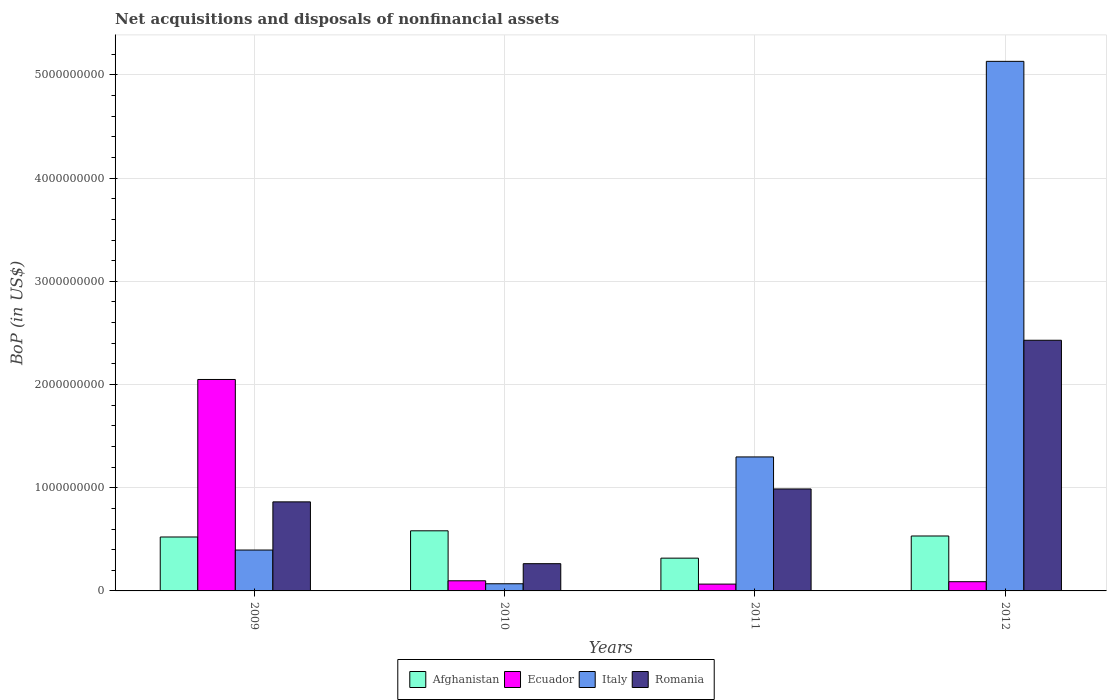How many bars are there on the 1st tick from the right?
Your answer should be compact. 4. What is the label of the 3rd group of bars from the left?
Provide a succinct answer. 2011. In how many cases, is the number of bars for a given year not equal to the number of legend labels?
Keep it short and to the point. 0. What is the Balance of Payments in Romania in 2012?
Your answer should be very brief. 2.43e+09. Across all years, what is the maximum Balance of Payments in Ecuador?
Keep it short and to the point. 2.05e+09. Across all years, what is the minimum Balance of Payments in Afghanistan?
Your response must be concise. 3.18e+08. In which year was the Balance of Payments in Afghanistan maximum?
Ensure brevity in your answer.  2010. What is the total Balance of Payments in Italy in the graph?
Your response must be concise. 6.90e+09. What is the difference between the Balance of Payments in Italy in 2009 and that in 2011?
Keep it short and to the point. -9.02e+08. What is the difference between the Balance of Payments in Italy in 2011 and the Balance of Payments in Ecuador in 2010?
Keep it short and to the point. 1.20e+09. What is the average Balance of Payments in Italy per year?
Offer a terse response. 1.72e+09. In the year 2012, what is the difference between the Balance of Payments in Afghanistan and Balance of Payments in Romania?
Offer a very short reply. -1.90e+09. What is the ratio of the Balance of Payments in Italy in 2009 to that in 2011?
Provide a succinct answer. 0.31. Is the difference between the Balance of Payments in Afghanistan in 2010 and 2011 greater than the difference between the Balance of Payments in Romania in 2010 and 2011?
Provide a succinct answer. Yes. What is the difference between the highest and the second highest Balance of Payments in Romania?
Your response must be concise. 1.44e+09. What is the difference between the highest and the lowest Balance of Payments in Afghanistan?
Ensure brevity in your answer.  2.65e+08. In how many years, is the Balance of Payments in Afghanistan greater than the average Balance of Payments in Afghanistan taken over all years?
Your response must be concise. 3. Is it the case that in every year, the sum of the Balance of Payments in Italy and Balance of Payments in Ecuador is greater than the sum of Balance of Payments in Romania and Balance of Payments in Afghanistan?
Provide a succinct answer. No. What does the 4th bar from the left in 2010 represents?
Give a very brief answer. Romania. What does the 3rd bar from the right in 2012 represents?
Make the answer very short. Ecuador. Is it the case that in every year, the sum of the Balance of Payments in Romania and Balance of Payments in Ecuador is greater than the Balance of Payments in Afghanistan?
Your answer should be compact. No. Are all the bars in the graph horizontal?
Ensure brevity in your answer.  No. What is the difference between two consecutive major ticks on the Y-axis?
Your answer should be compact. 1.00e+09. Are the values on the major ticks of Y-axis written in scientific E-notation?
Offer a terse response. No. How many legend labels are there?
Give a very brief answer. 4. How are the legend labels stacked?
Provide a succinct answer. Horizontal. What is the title of the graph?
Your answer should be compact. Net acquisitions and disposals of nonfinancial assets. Does "Europe(all income levels)" appear as one of the legend labels in the graph?
Offer a terse response. No. What is the label or title of the X-axis?
Ensure brevity in your answer.  Years. What is the label or title of the Y-axis?
Offer a very short reply. BoP (in US$). What is the BoP (in US$) in Afghanistan in 2009?
Keep it short and to the point. 5.23e+08. What is the BoP (in US$) in Ecuador in 2009?
Offer a very short reply. 2.05e+09. What is the BoP (in US$) in Italy in 2009?
Offer a terse response. 3.96e+08. What is the BoP (in US$) of Romania in 2009?
Keep it short and to the point. 8.63e+08. What is the BoP (in US$) of Afghanistan in 2010?
Offer a very short reply. 5.83e+08. What is the BoP (in US$) in Ecuador in 2010?
Give a very brief answer. 9.82e+07. What is the BoP (in US$) of Italy in 2010?
Provide a short and direct response. 6.94e+07. What is the BoP (in US$) in Romania in 2010?
Offer a terse response. 2.64e+08. What is the BoP (in US$) of Afghanistan in 2011?
Your response must be concise. 3.18e+08. What is the BoP (in US$) in Ecuador in 2011?
Give a very brief answer. 6.60e+07. What is the BoP (in US$) in Italy in 2011?
Your answer should be very brief. 1.30e+09. What is the BoP (in US$) of Romania in 2011?
Your response must be concise. 9.88e+08. What is the BoP (in US$) of Afghanistan in 2012?
Provide a short and direct response. 5.32e+08. What is the BoP (in US$) of Ecuador in 2012?
Your answer should be very brief. 8.94e+07. What is the BoP (in US$) of Italy in 2012?
Make the answer very short. 5.13e+09. What is the BoP (in US$) of Romania in 2012?
Your answer should be very brief. 2.43e+09. Across all years, what is the maximum BoP (in US$) of Afghanistan?
Ensure brevity in your answer.  5.83e+08. Across all years, what is the maximum BoP (in US$) of Ecuador?
Provide a succinct answer. 2.05e+09. Across all years, what is the maximum BoP (in US$) of Italy?
Keep it short and to the point. 5.13e+09. Across all years, what is the maximum BoP (in US$) in Romania?
Provide a succinct answer. 2.43e+09. Across all years, what is the minimum BoP (in US$) of Afghanistan?
Make the answer very short. 3.18e+08. Across all years, what is the minimum BoP (in US$) in Ecuador?
Provide a succinct answer. 6.60e+07. Across all years, what is the minimum BoP (in US$) in Italy?
Your response must be concise. 6.94e+07. Across all years, what is the minimum BoP (in US$) in Romania?
Your answer should be compact. 2.64e+08. What is the total BoP (in US$) in Afghanistan in the graph?
Keep it short and to the point. 1.95e+09. What is the total BoP (in US$) in Ecuador in the graph?
Your answer should be very brief. 2.30e+09. What is the total BoP (in US$) of Italy in the graph?
Your answer should be very brief. 6.90e+09. What is the total BoP (in US$) of Romania in the graph?
Provide a succinct answer. 4.54e+09. What is the difference between the BoP (in US$) in Afghanistan in 2009 and that in 2010?
Give a very brief answer. -6.00e+07. What is the difference between the BoP (in US$) of Ecuador in 2009 and that in 2010?
Give a very brief answer. 1.95e+09. What is the difference between the BoP (in US$) in Italy in 2009 and that in 2010?
Your answer should be compact. 3.27e+08. What is the difference between the BoP (in US$) of Romania in 2009 and that in 2010?
Give a very brief answer. 5.99e+08. What is the difference between the BoP (in US$) of Afghanistan in 2009 and that in 2011?
Offer a terse response. 2.05e+08. What is the difference between the BoP (in US$) of Ecuador in 2009 and that in 2011?
Give a very brief answer. 1.98e+09. What is the difference between the BoP (in US$) of Italy in 2009 and that in 2011?
Make the answer very short. -9.02e+08. What is the difference between the BoP (in US$) in Romania in 2009 and that in 2011?
Give a very brief answer. -1.25e+08. What is the difference between the BoP (in US$) of Afghanistan in 2009 and that in 2012?
Make the answer very short. -9.77e+06. What is the difference between the BoP (in US$) of Ecuador in 2009 and that in 2012?
Your response must be concise. 1.96e+09. What is the difference between the BoP (in US$) in Italy in 2009 and that in 2012?
Provide a short and direct response. -4.74e+09. What is the difference between the BoP (in US$) of Romania in 2009 and that in 2012?
Provide a short and direct response. -1.57e+09. What is the difference between the BoP (in US$) in Afghanistan in 2010 and that in 2011?
Keep it short and to the point. 2.65e+08. What is the difference between the BoP (in US$) of Ecuador in 2010 and that in 2011?
Make the answer very short. 3.22e+07. What is the difference between the BoP (in US$) of Italy in 2010 and that in 2011?
Ensure brevity in your answer.  -1.23e+09. What is the difference between the BoP (in US$) of Romania in 2010 and that in 2011?
Your answer should be compact. -7.24e+08. What is the difference between the BoP (in US$) of Afghanistan in 2010 and that in 2012?
Give a very brief answer. 5.02e+07. What is the difference between the BoP (in US$) in Ecuador in 2010 and that in 2012?
Offer a terse response. 8.86e+06. What is the difference between the BoP (in US$) of Italy in 2010 and that in 2012?
Make the answer very short. -5.06e+09. What is the difference between the BoP (in US$) in Romania in 2010 and that in 2012?
Offer a terse response. -2.16e+09. What is the difference between the BoP (in US$) in Afghanistan in 2011 and that in 2012?
Your answer should be compact. -2.15e+08. What is the difference between the BoP (in US$) of Ecuador in 2011 and that in 2012?
Your answer should be compact. -2.34e+07. What is the difference between the BoP (in US$) of Italy in 2011 and that in 2012?
Ensure brevity in your answer.  -3.83e+09. What is the difference between the BoP (in US$) in Romania in 2011 and that in 2012?
Your answer should be very brief. -1.44e+09. What is the difference between the BoP (in US$) in Afghanistan in 2009 and the BoP (in US$) in Ecuador in 2010?
Offer a very short reply. 4.24e+08. What is the difference between the BoP (in US$) in Afghanistan in 2009 and the BoP (in US$) in Italy in 2010?
Give a very brief answer. 4.53e+08. What is the difference between the BoP (in US$) of Afghanistan in 2009 and the BoP (in US$) of Romania in 2010?
Your answer should be very brief. 2.59e+08. What is the difference between the BoP (in US$) of Ecuador in 2009 and the BoP (in US$) of Italy in 2010?
Offer a terse response. 1.98e+09. What is the difference between the BoP (in US$) of Ecuador in 2009 and the BoP (in US$) of Romania in 2010?
Keep it short and to the point. 1.78e+09. What is the difference between the BoP (in US$) in Italy in 2009 and the BoP (in US$) in Romania in 2010?
Give a very brief answer. 1.32e+08. What is the difference between the BoP (in US$) of Afghanistan in 2009 and the BoP (in US$) of Ecuador in 2011?
Your answer should be compact. 4.57e+08. What is the difference between the BoP (in US$) of Afghanistan in 2009 and the BoP (in US$) of Italy in 2011?
Offer a terse response. -7.76e+08. What is the difference between the BoP (in US$) in Afghanistan in 2009 and the BoP (in US$) in Romania in 2011?
Offer a terse response. -4.65e+08. What is the difference between the BoP (in US$) in Ecuador in 2009 and the BoP (in US$) in Italy in 2011?
Keep it short and to the point. 7.51e+08. What is the difference between the BoP (in US$) of Ecuador in 2009 and the BoP (in US$) of Romania in 2011?
Ensure brevity in your answer.  1.06e+09. What is the difference between the BoP (in US$) of Italy in 2009 and the BoP (in US$) of Romania in 2011?
Offer a terse response. -5.92e+08. What is the difference between the BoP (in US$) in Afghanistan in 2009 and the BoP (in US$) in Ecuador in 2012?
Ensure brevity in your answer.  4.33e+08. What is the difference between the BoP (in US$) in Afghanistan in 2009 and the BoP (in US$) in Italy in 2012?
Offer a terse response. -4.61e+09. What is the difference between the BoP (in US$) of Afghanistan in 2009 and the BoP (in US$) of Romania in 2012?
Give a very brief answer. -1.91e+09. What is the difference between the BoP (in US$) in Ecuador in 2009 and the BoP (in US$) in Italy in 2012?
Keep it short and to the point. -3.08e+09. What is the difference between the BoP (in US$) in Ecuador in 2009 and the BoP (in US$) in Romania in 2012?
Give a very brief answer. -3.80e+08. What is the difference between the BoP (in US$) of Italy in 2009 and the BoP (in US$) of Romania in 2012?
Provide a succinct answer. -2.03e+09. What is the difference between the BoP (in US$) of Afghanistan in 2010 and the BoP (in US$) of Ecuador in 2011?
Make the answer very short. 5.17e+08. What is the difference between the BoP (in US$) in Afghanistan in 2010 and the BoP (in US$) in Italy in 2011?
Provide a short and direct response. -7.16e+08. What is the difference between the BoP (in US$) in Afghanistan in 2010 and the BoP (in US$) in Romania in 2011?
Offer a very short reply. -4.05e+08. What is the difference between the BoP (in US$) of Ecuador in 2010 and the BoP (in US$) of Italy in 2011?
Provide a succinct answer. -1.20e+09. What is the difference between the BoP (in US$) in Ecuador in 2010 and the BoP (in US$) in Romania in 2011?
Give a very brief answer. -8.90e+08. What is the difference between the BoP (in US$) of Italy in 2010 and the BoP (in US$) of Romania in 2011?
Provide a short and direct response. -9.19e+08. What is the difference between the BoP (in US$) of Afghanistan in 2010 and the BoP (in US$) of Ecuador in 2012?
Offer a terse response. 4.93e+08. What is the difference between the BoP (in US$) in Afghanistan in 2010 and the BoP (in US$) in Italy in 2012?
Make the answer very short. -4.55e+09. What is the difference between the BoP (in US$) in Afghanistan in 2010 and the BoP (in US$) in Romania in 2012?
Provide a short and direct response. -1.85e+09. What is the difference between the BoP (in US$) of Ecuador in 2010 and the BoP (in US$) of Italy in 2012?
Ensure brevity in your answer.  -5.03e+09. What is the difference between the BoP (in US$) of Ecuador in 2010 and the BoP (in US$) of Romania in 2012?
Offer a very short reply. -2.33e+09. What is the difference between the BoP (in US$) in Italy in 2010 and the BoP (in US$) in Romania in 2012?
Offer a very short reply. -2.36e+09. What is the difference between the BoP (in US$) of Afghanistan in 2011 and the BoP (in US$) of Ecuador in 2012?
Your answer should be very brief. 2.28e+08. What is the difference between the BoP (in US$) of Afghanistan in 2011 and the BoP (in US$) of Italy in 2012?
Your answer should be very brief. -4.81e+09. What is the difference between the BoP (in US$) of Afghanistan in 2011 and the BoP (in US$) of Romania in 2012?
Your answer should be compact. -2.11e+09. What is the difference between the BoP (in US$) in Ecuador in 2011 and the BoP (in US$) in Italy in 2012?
Keep it short and to the point. -5.07e+09. What is the difference between the BoP (in US$) of Ecuador in 2011 and the BoP (in US$) of Romania in 2012?
Your response must be concise. -2.36e+09. What is the difference between the BoP (in US$) in Italy in 2011 and the BoP (in US$) in Romania in 2012?
Offer a terse response. -1.13e+09. What is the average BoP (in US$) in Afghanistan per year?
Offer a very short reply. 4.89e+08. What is the average BoP (in US$) of Ecuador per year?
Your answer should be very brief. 5.76e+08. What is the average BoP (in US$) in Italy per year?
Offer a very short reply. 1.72e+09. What is the average BoP (in US$) in Romania per year?
Keep it short and to the point. 1.14e+09. In the year 2009, what is the difference between the BoP (in US$) in Afghanistan and BoP (in US$) in Ecuador?
Make the answer very short. -1.53e+09. In the year 2009, what is the difference between the BoP (in US$) of Afghanistan and BoP (in US$) of Italy?
Provide a short and direct response. 1.26e+08. In the year 2009, what is the difference between the BoP (in US$) in Afghanistan and BoP (in US$) in Romania?
Make the answer very short. -3.40e+08. In the year 2009, what is the difference between the BoP (in US$) of Ecuador and BoP (in US$) of Italy?
Provide a succinct answer. 1.65e+09. In the year 2009, what is the difference between the BoP (in US$) of Ecuador and BoP (in US$) of Romania?
Offer a very short reply. 1.19e+09. In the year 2009, what is the difference between the BoP (in US$) in Italy and BoP (in US$) in Romania?
Give a very brief answer. -4.67e+08. In the year 2010, what is the difference between the BoP (in US$) in Afghanistan and BoP (in US$) in Ecuador?
Keep it short and to the point. 4.84e+08. In the year 2010, what is the difference between the BoP (in US$) in Afghanistan and BoP (in US$) in Italy?
Offer a terse response. 5.13e+08. In the year 2010, what is the difference between the BoP (in US$) in Afghanistan and BoP (in US$) in Romania?
Offer a very short reply. 3.19e+08. In the year 2010, what is the difference between the BoP (in US$) of Ecuador and BoP (in US$) of Italy?
Keep it short and to the point. 2.89e+07. In the year 2010, what is the difference between the BoP (in US$) of Ecuador and BoP (in US$) of Romania?
Keep it short and to the point. -1.66e+08. In the year 2010, what is the difference between the BoP (in US$) in Italy and BoP (in US$) in Romania?
Your answer should be compact. -1.95e+08. In the year 2011, what is the difference between the BoP (in US$) in Afghanistan and BoP (in US$) in Ecuador?
Ensure brevity in your answer.  2.52e+08. In the year 2011, what is the difference between the BoP (in US$) in Afghanistan and BoP (in US$) in Italy?
Offer a terse response. -9.81e+08. In the year 2011, what is the difference between the BoP (in US$) in Afghanistan and BoP (in US$) in Romania?
Your response must be concise. -6.70e+08. In the year 2011, what is the difference between the BoP (in US$) in Ecuador and BoP (in US$) in Italy?
Your answer should be very brief. -1.23e+09. In the year 2011, what is the difference between the BoP (in US$) in Ecuador and BoP (in US$) in Romania?
Your answer should be compact. -9.22e+08. In the year 2011, what is the difference between the BoP (in US$) in Italy and BoP (in US$) in Romania?
Your answer should be compact. 3.10e+08. In the year 2012, what is the difference between the BoP (in US$) of Afghanistan and BoP (in US$) of Ecuador?
Offer a very short reply. 4.43e+08. In the year 2012, what is the difference between the BoP (in US$) of Afghanistan and BoP (in US$) of Italy?
Your answer should be compact. -4.60e+09. In the year 2012, what is the difference between the BoP (in US$) in Afghanistan and BoP (in US$) in Romania?
Your answer should be very brief. -1.90e+09. In the year 2012, what is the difference between the BoP (in US$) of Ecuador and BoP (in US$) of Italy?
Provide a succinct answer. -5.04e+09. In the year 2012, what is the difference between the BoP (in US$) of Ecuador and BoP (in US$) of Romania?
Ensure brevity in your answer.  -2.34e+09. In the year 2012, what is the difference between the BoP (in US$) in Italy and BoP (in US$) in Romania?
Provide a short and direct response. 2.70e+09. What is the ratio of the BoP (in US$) of Afghanistan in 2009 to that in 2010?
Your response must be concise. 0.9. What is the ratio of the BoP (in US$) of Ecuador in 2009 to that in 2010?
Offer a very short reply. 20.86. What is the ratio of the BoP (in US$) of Italy in 2009 to that in 2010?
Offer a very short reply. 5.71. What is the ratio of the BoP (in US$) of Romania in 2009 to that in 2010?
Your answer should be compact. 3.27. What is the ratio of the BoP (in US$) of Afghanistan in 2009 to that in 2011?
Ensure brevity in your answer.  1.65. What is the ratio of the BoP (in US$) of Ecuador in 2009 to that in 2011?
Your answer should be compact. 31.04. What is the ratio of the BoP (in US$) in Italy in 2009 to that in 2011?
Your answer should be very brief. 0.31. What is the ratio of the BoP (in US$) in Romania in 2009 to that in 2011?
Your answer should be very brief. 0.87. What is the ratio of the BoP (in US$) in Afghanistan in 2009 to that in 2012?
Offer a very short reply. 0.98. What is the ratio of the BoP (in US$) of Ecuador in 2009 to that in 2012?
Give a very brief answer. 22.92. What is the ratio of the BoP (in US$) in Italy in 2009 to that in 2012?
Provide a short and direct response. 0.08. What is the ratio of the BoP (in US$) in Romania in 2009 to that in 2012?
Your answer should be compact. 0.36. What is the ratio of the BoP (in US$) in Afghanistan in 2010 to that in 2011?
Give a very brief answer. 1.83. What is the ratio of the BoP (in US$) in Ecuador in 2010 to that in 2011?
Provide a short and direct response. 1.49. What is the ratio of the BoP (in US$) of Italy in 2010 to that in 2011?
Provide a short and direct response. 0.05. What is the ratio of the BoP (in US$) in Romania in 2010 to that in 2011?
Give a very brief answer. 0.27. What is the ratio of the BoP (in US$) of Afghanistan in 2010 to that in 2012?
Make the answer very short. 1.09. What is the ratio of the BoP (in US$) of Ecuador in 2010 to that in 2012?
Give a very brief answer. 1.1. What is the ratio of the BoP (in US$) of Italy in 2010 to that in 2012?
Give a very brief answer. 0.01. What is the ratio of the BoP (in US$) in Romania in 2010 to that in 2012?
Your answer should be compact. 0.11. What is the ratio of the BoP (in US$) of Afghanistan in 2011 to that in 2012?
Your answer should be compact. 0.6. What is the ratio of the BoP (in US$) in Ecuador in 2011 to that in 2012?
Your answer should be very brief. 0.74. What is the ratio of the BoP (in US$) in Italy in 2011 to that in 2012?
Provide a succinct answer. 0.25. What is the ratio of the BoP (in US$) of Romania in 2011 to that in 2012?
Your answer should be compact. 0.41. What is the difference between the highest and the second highest BoP (in US$) in Afghanistan?
Keep it short and to the point. 5.02e+07. What is the difference between the highest and the second highest BoP (in US$) of Ecuador?
Provide a succinct answer. 1.95e+09. What is the difference between the highest and the second highest BoP (in US$) of Italy?
Make the answer very short. 3.83e+09. What is the difference between the highest and the second highest BoP (in US$) of Romania?
Make the answer very short. 1.44e+09. What is the difference between the highest and the lowest BoP (in US$) of Afghanistan?
Make the answer very short. 2.65e+08. What is the difference between the highest and the lowest BoP (in US$) in Ecuador?
Your response must be concise. 1.98e+09. What is the difference between the highest and the lowest BoP (in US$) in Italy?
Provide a succinct answer. 5.06e+09. What is the difference between the highest and the lowest BoP (in US$) in Romania?
Offer a very short reply. 2.16e+09. 